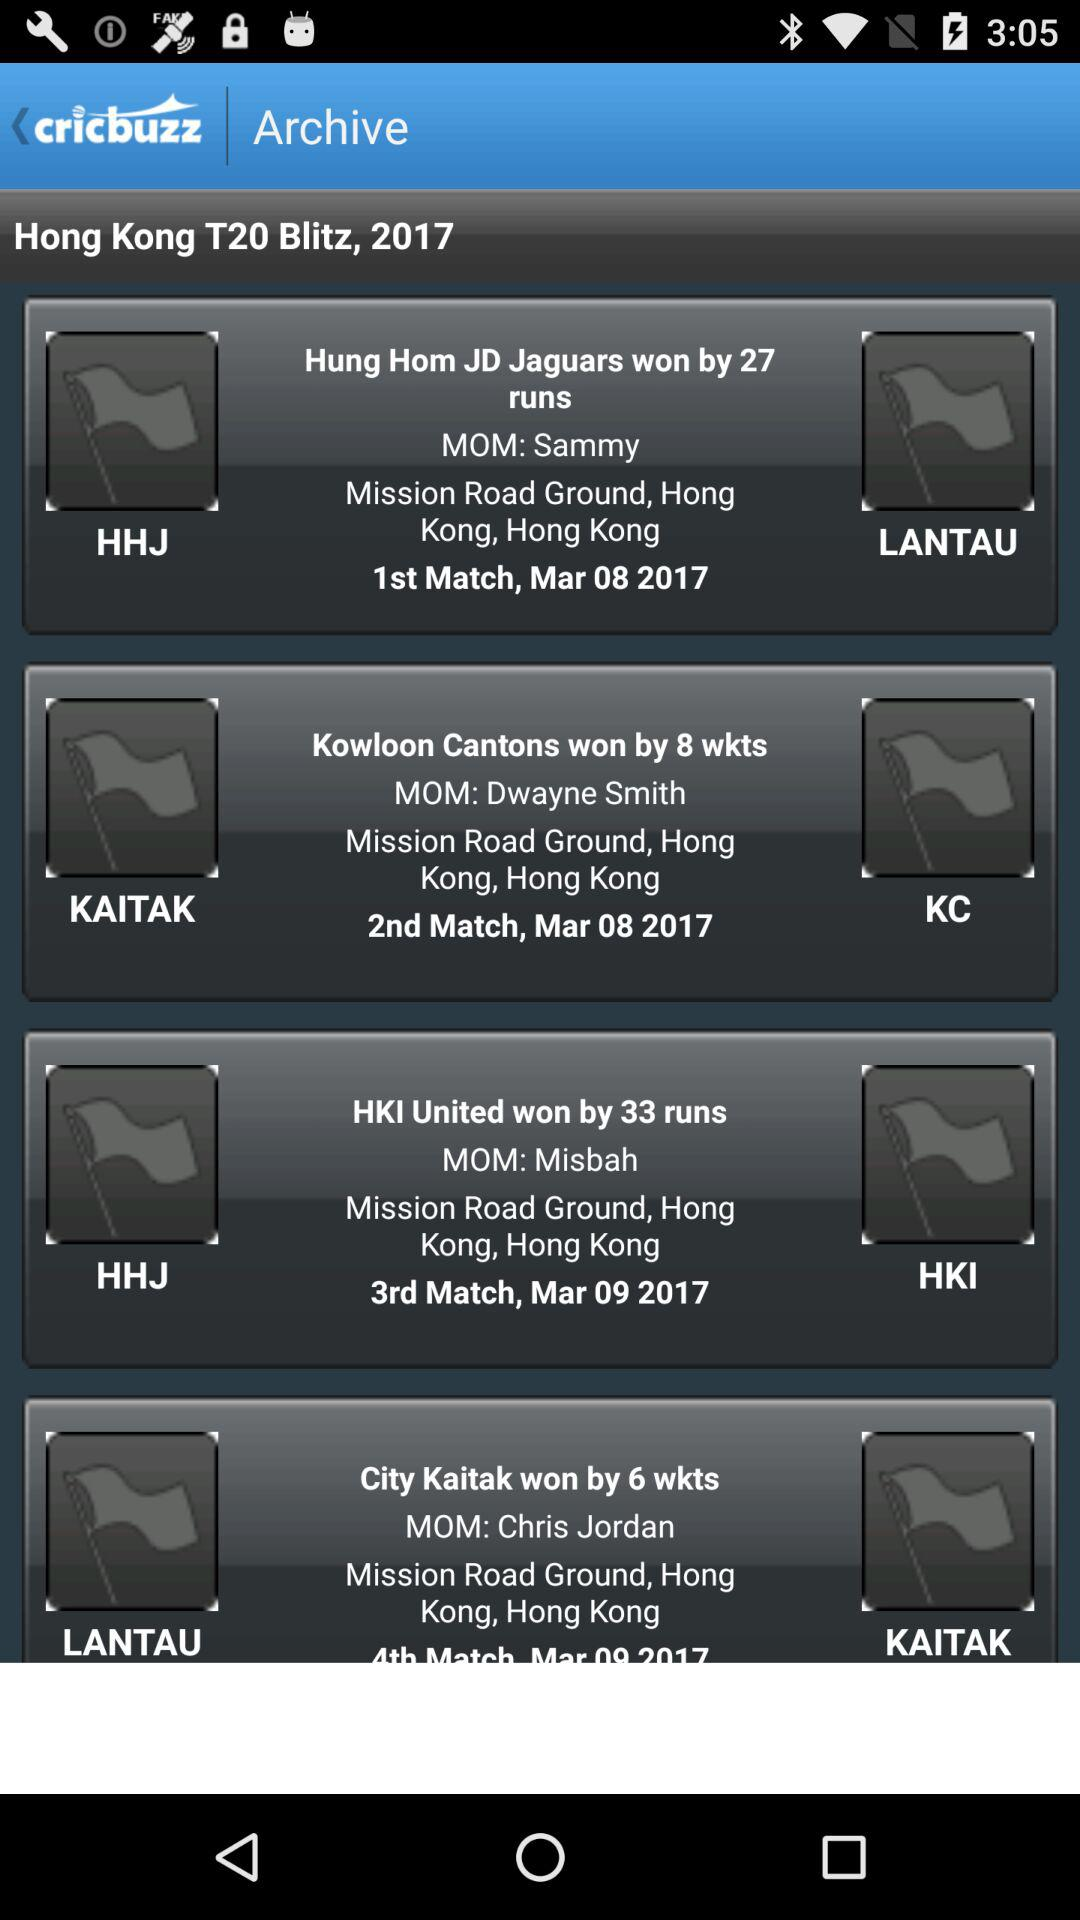Who won the 2nd match? The second match was won by "Kowloon Cantons". 